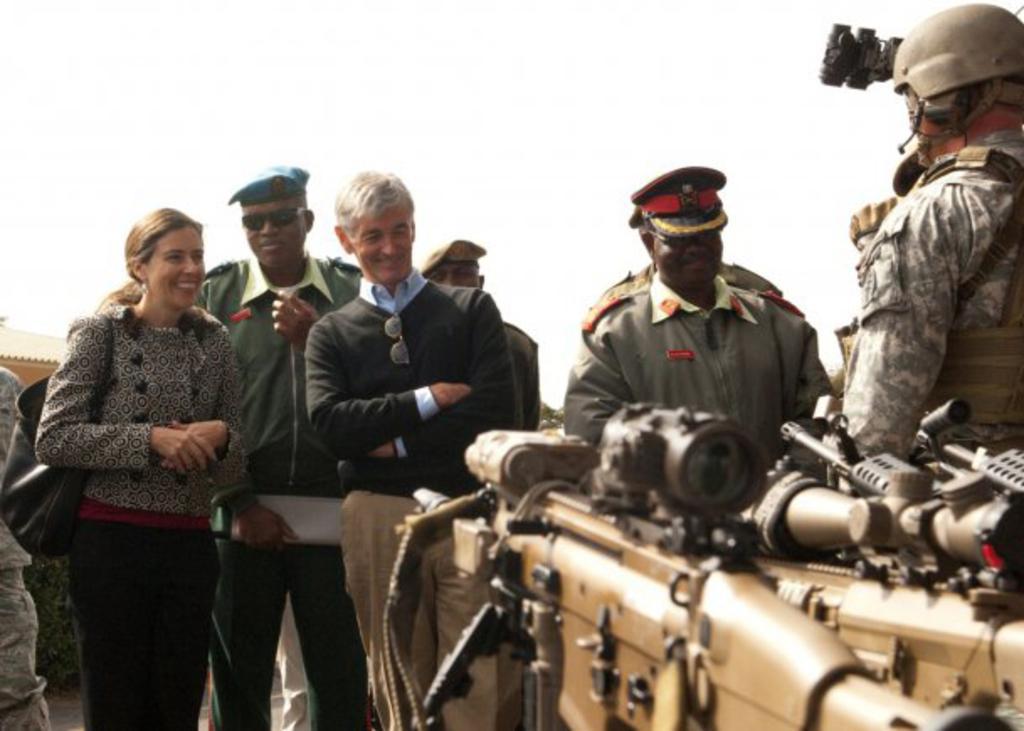Please provide a concise description of this image. In the picture I can see a few persons. I can see a man on the left side is wearing a sweater and there is a smile on his face. There is a woman on the left side is carrying a black color bag and she is smiling as well. It is looking like a defense force special vehicle on the right side. 